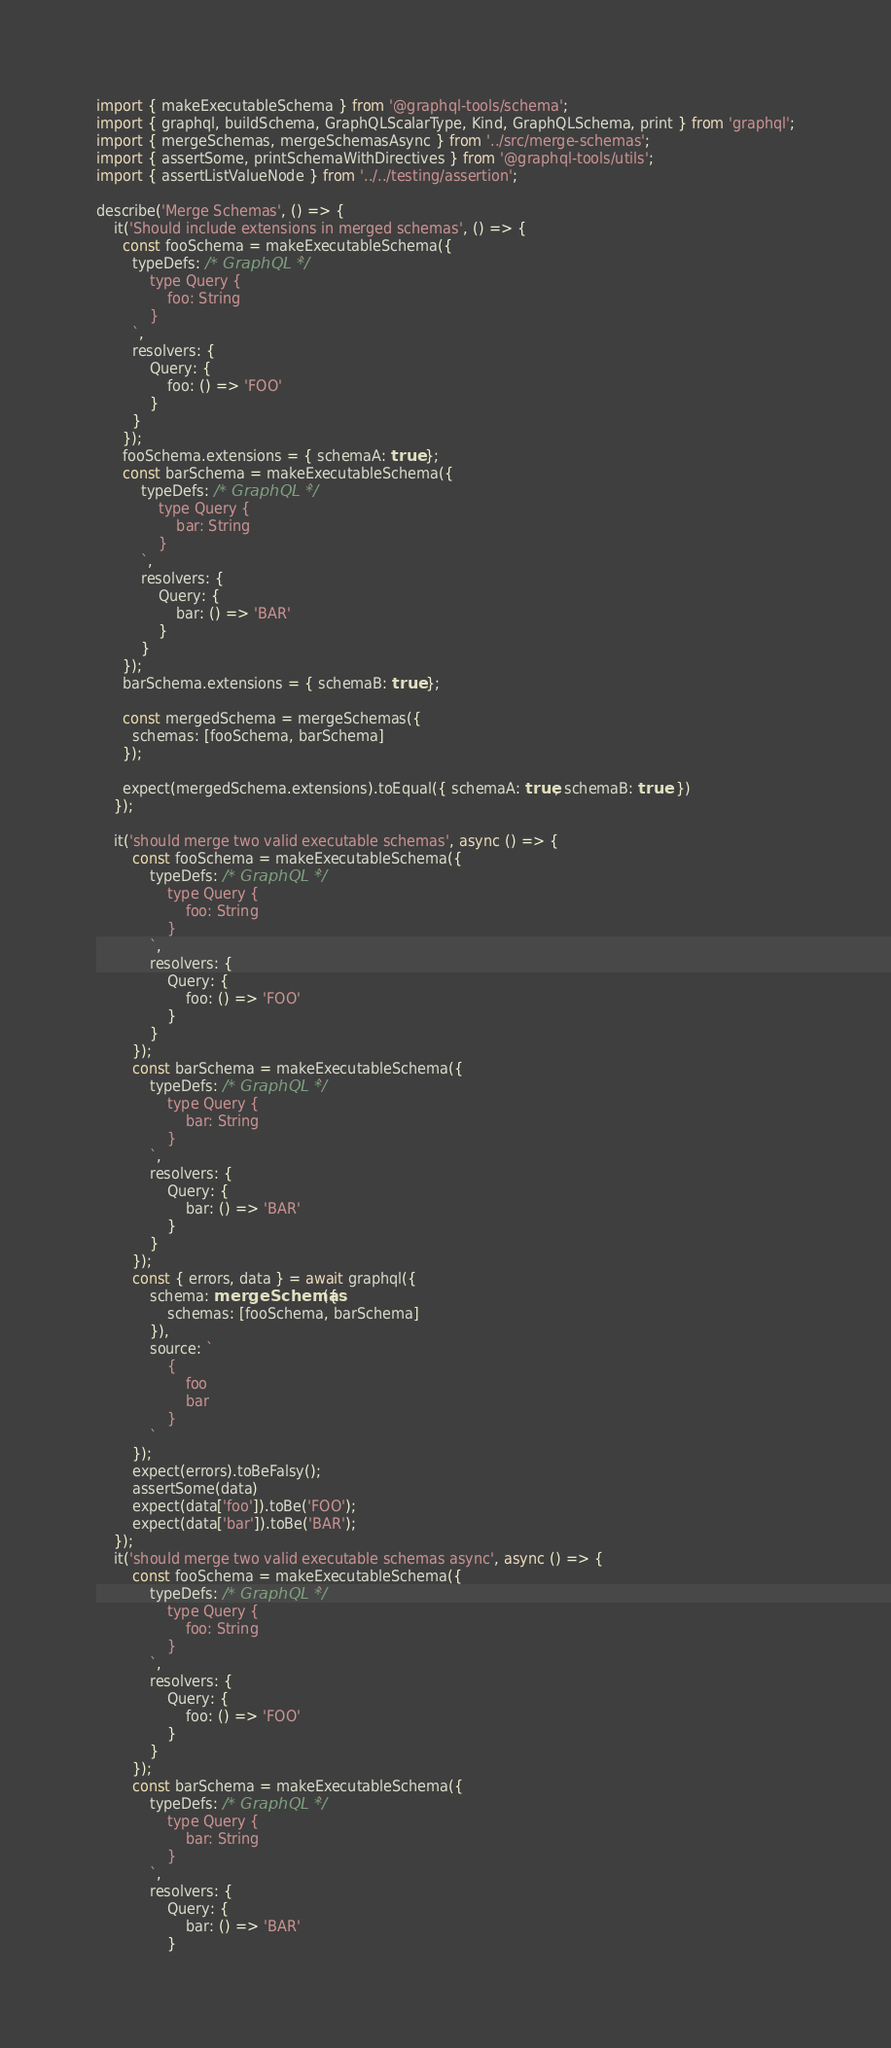<code> <loc_0><loc_0><loc_500><loc_500><_TypeScript_>import { makeExecutableSchema } from '@graphql-tools/schema';
import { graphql, buildSchema, GraphQLScalarType, Kind, GraphQLSchema, print } from 'graphql';
import { mergeSchemas, mergeSchemasAsync } from '../src/merge-schemas';
import { assertSome, printSchemaWithDirectives } from '@graphql-tools/utils';
import { assertListValueNode } from '../../testing/assertion';

describe('Merge Schemas', () => {
    it('Should include extensions in merged schemas', () => {
      const fooSchema = makeExecutableSchema({
        typeDefs: /* GraphQL */`
            type Query {
                foo: String
            }
        `,
        resolvers: {
            Query: {
                foo: () => 'FOO'
            }
        }
      });
      fooSchema.extensions = { schemaA: true };
      const barSchema = makeExecutableSchema({
          typeDefs: /* GraphQL */`
              type Query {
                  bar: String
              }
          `,
          resolvers: {
              Query: {
                  bar: () => 'BAR'
              }
          }
      });
      barSchema.extensions = { schemaB: true };

      const mergedSchema = mergeSchemas({
        schemas: [fooSchema, barSchema]
      });

      expect(mergedSchema.extensions).toEqual({ schemaA: true, schemaB: true  })
    });

    it('should merge two valid executable schemas', async () => {
        const fooSchema = makeExecutableSchema({
            typeDefs: /* GraphQL */`
                type Query {
                    foo: String
                }
            `,
            resolvers: {
                Query: {
                    foo: () => 'FOO'
                }
            }
        });
        const barSchema = makeExecutableSchema({
            typeDefs: /* GraphQL */`
                type Query {
                    bar: String
                }
            `,
            resolvers: {
                Query: {
                    bar: () => 'BAR'
                }
            }
        });
        const { errors, data } = await graphql({
            schema: mergeSchemas({
                schemas: [fooSchema, barSchema]
            }),
            source: `
                {
                    foo
                    bar
                }
            `
        });
        expect(errors).toBeFalsy();
        assertSome(data)
        expect(data['foo']).toBe('FOO');
        expect(data['bar']).toBe('BAR');
    });
    it('should merge two valid executable schemas async', async () => {
        const fooSchema = makeExecutableSchema({
            typeDefs: /* GraphQL */`
                type Query {
                    foo: String
                }
            `,
            resolvers: {
                Query: {
                    foo: () => 'FOO'
                }
            }
        });
        const barSchema = makeExecutableSchema({
            typeDefs: /* GraphQL */`
                type Query {
                    bar: String
                }
            `,
            resolvers: {
                Query: {
                    bar: () => 'BAR'
                }</code> 